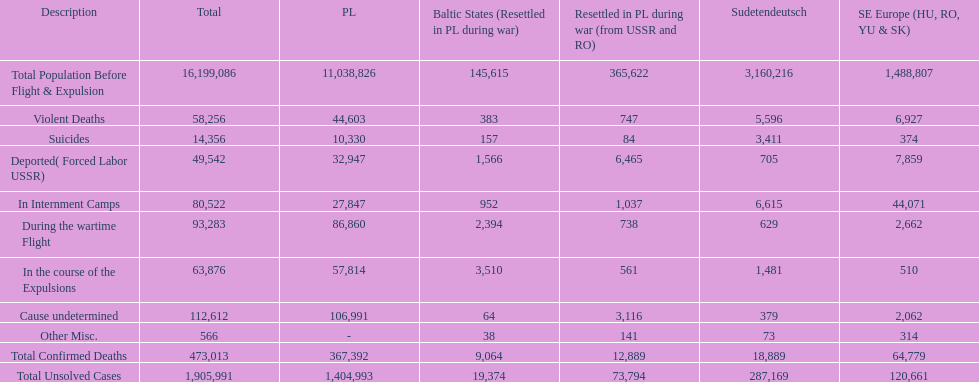What were the total number of confirmed deaths? 473,013. Of these, how many were violent? 58,256. 